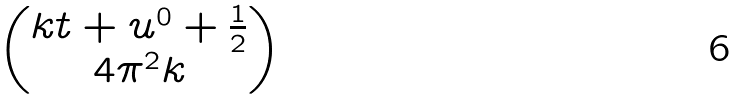Convert formula to latex. <formula><loc_0><loc_0><loc_500><loc_500>\begin{pmatrix} k t + u ^ { 0 } + \frac { 1 } { 2 } \\ 4 \pi ^ { 2 } k \end{pmatrix}</formula> 